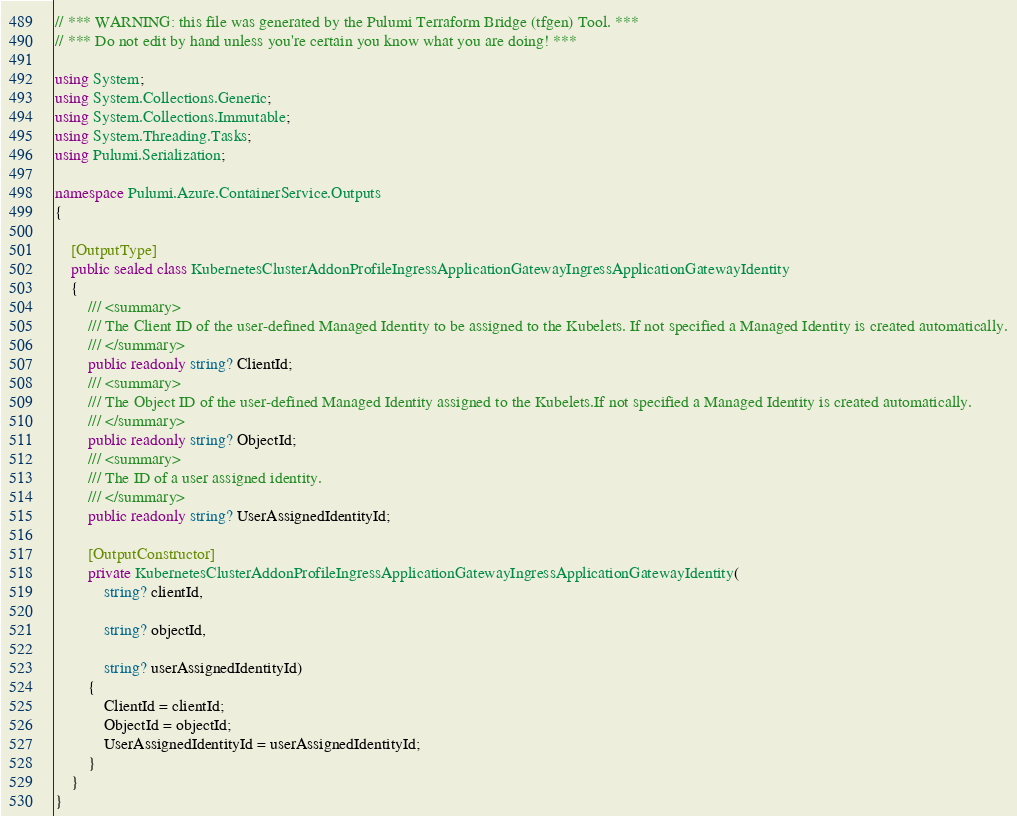Convert code to text. <code><loc_0><loc_0><loc_500><loc_500><_C#_>// *** WARNING: this file was generated by the Pulumi Terraform Bridge (tfgen) Tool. ***
// *** Do not edit by hand unless you're certain you know what you are doing! ***

using System;
using System.Collections.Generic;
using System.Collections.Immutable;
using System.Threading.Tasks;
using Pulumi.Serialization;

namespace Pulumi.Azure.ContainerService.Outputs
{

    [OutputType]
    public sealed class KubernetesClusterAddonProfileIngressApplicationGatewayIngressApplicationGatewayIdentity
    {
        /// <summary>
        /// The Client ID of the user-defined Managed Identity to be assigned to the Kubelets. If not specified a Managed Identity is created automatically.
        /// </summary>
        public readonly string? ClientId;
        /// <summary>
        /// The Object ID of the user-defined Managed Identity assigned to the Kubelets.If not specified a Managed Identity is created automatically.
        /// </summary>
        public readonly string? ObjectId;
        /// <summary>
        /// The ID of a user assigned identity.
        /// </summary>
        public readonly string? UserAssignedIdentityId;

        [OutputConstructor]
        private KubernetesClusterAddonProfileIngressApplicationGatewayIngressApplicationGatewayIdentity(
            string? clientId,

            string? objectId,

            string? userAssignedIdentityId)
        {
            ClientId = clientId;
            ObjectId = objectId;
            UserAssignedIdentityId = userAssignedIdentityId;
        }
    }
}
</code> 